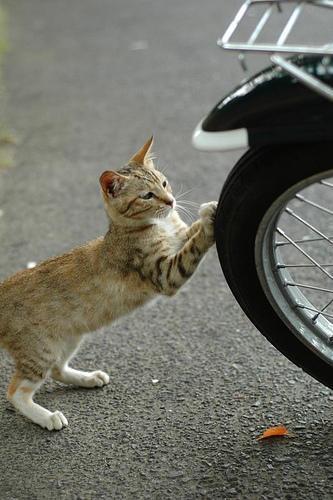How many giraffes are there?
Give a very brief answer. 0. 